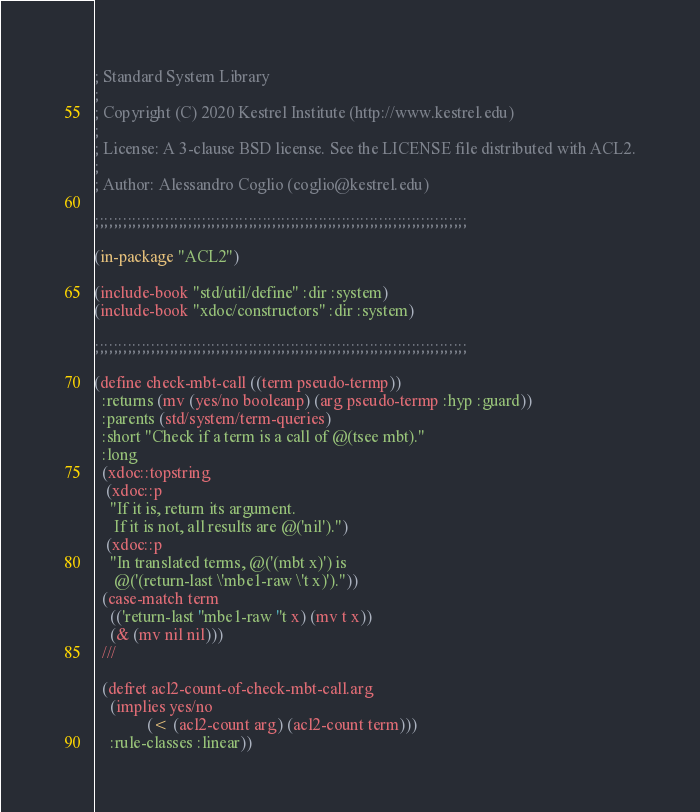Convert code to text. <code><loc_0><loc_0><loc_500><loc_500><_Lisp_>; Standard System Library
;
; Copyright (C) 2020 Kestrel Institute (http://www.kestrel.edu)
;
; License: A 3-clause BSD license. See the LICENSE file distributed with ACL2.
;
; Author: Alessandro Coglio (coglio@kestrel.edu)

;;;;;;;;;;;;;;;;;;;;;;;;;;;;;;;;;;;;;;;;;;;;;;;;;;;;;;;;;;;;;;;;;;;;;;;;;;;;;;;;

(in-package "ACL2")

(include-book "std/util/define" :dir :system)
(include-book "xdoc/constructors" :dir :system)

;;;;;;;;;;;;;;;;;;;;;;;;;;;;;;;;;;;;;;;;;;;;;;;;;;;;;;;;;;;;;;;;;;;;;;;;;;;;;;;;

(define check-mbt-call ((term pseudo-termp))
  :returns (mv (yes/no booleanp) (arg pseudo-termp :hyp :guard))
  :parents (std/system/term-queries)
  :short "Check if a term is a call of @(tsee mbt)."
  :long
  (xdoc::topstring
   (xdoc::p
    "If it is, return its argument.
     If it is not, all results are @('nil').")
   (xdoc::p
    "In translated terms, @('(mbt x)') is
     @('(return-last \'mbe1-raw \'t x)')."))
  (case-match term
    (('return-last ''mbe1-raw ''t x) (mv t x))
    (& (mv nil nil)))
  ///

  (defret acl2-count-of-check-mbt-call.arg
    (implies yes/no
             (< (acl2-count arg) (acl2-count term)))
    :rule-classes :linear))
</code> 